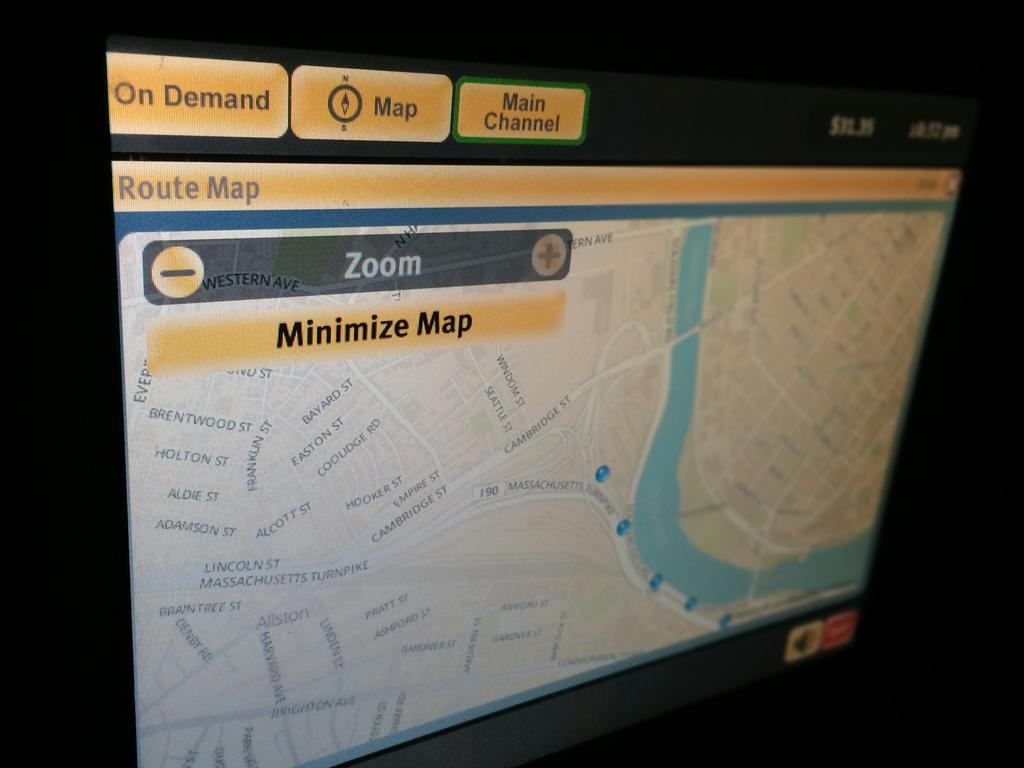<image>
Relay a brief, clear account of the picture shown. A route map that has the options to zoom and minimize the map. 